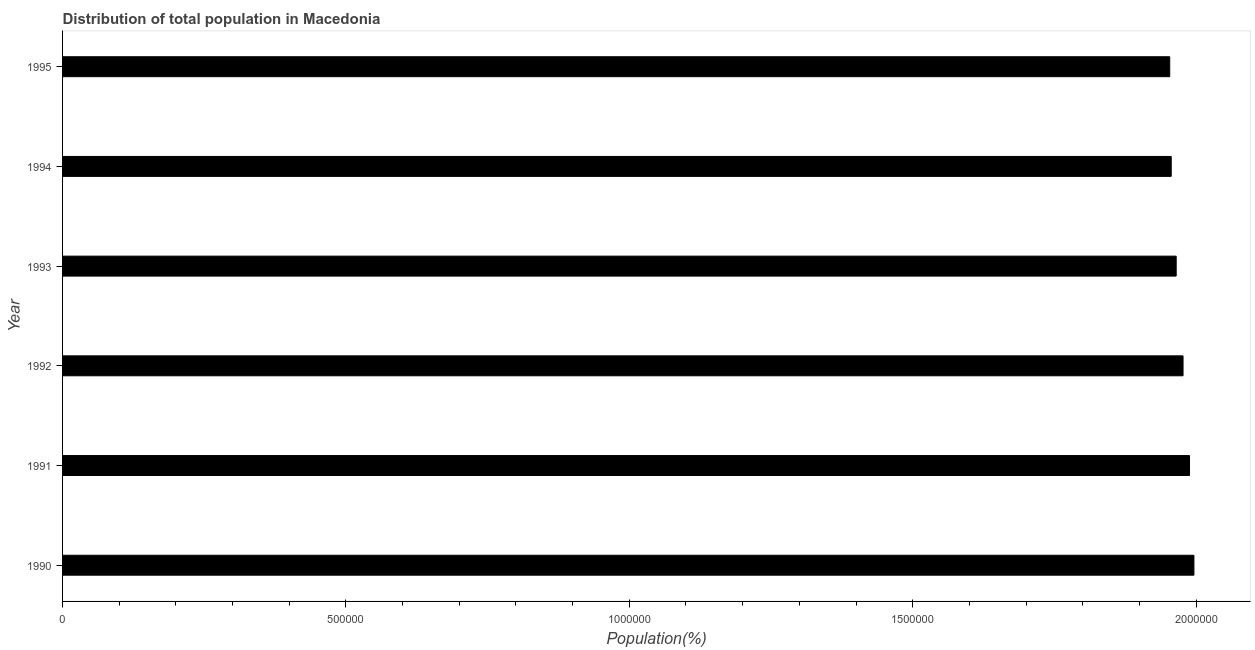What is the title of the graph?
Ensure brevity in your answer.  Distribution of total population in Macedonia . What is the label or title of the X-axis?
Your answer should be very brief. Population(%). What is the population in 1993?
Offer a terse response. 1.96e+06. Across all years, what is the maximum population?
Provide a short and direct response. 2.00e+06. Across all years, what is the minimum population?
Provide a succinct answer. 1.95e+06. In which year was the population maximum?
Your answer should be very brief. 1990. What is the sum of the population?
Give a very brief answer. 1.18e+07. What is the difference between the population in 1991 and 1994?
Your answer should be compact. 3.23e+04. What is the average population per year?
Provide a succinct answer. 1.97e+06. What is the median population?
Keep it short and to the point. 1.97e+06. Do a majority of the years between 1995 and 1994 (inclusive) have population greater than 1300000 %?
Provide a short and direct response. No. What is the ratio of the population in 1992 to that in 1995?
Your answer should be very brief. 1.01. Is the difference between the population in 1991 and 1995 greater than the difference between any two years?
Keep it short and to the point. No. What is the difference between the highest and the second highest population?
Give a very brief answer. 7769. Is the sum of the population in 1990 and 1994 greater than the maximum population across all years?
Provide a succinct answer. Yes. What is the difference between the highest and the lowest population?
Your answer should be very brief. 4.27e+04. Are the values on the major ticks of X-axis written in scientific E-notation?
Your response must be concise. No. What is the Population(%) of 1990?
Ensure brevity in your answer.  2.00e+06. What is the Population(%) of 1991?
Offer a very short reply. 1.99e+06. What is the Population(%) in 1992?
Provide a short and direct response. 1.98e+06. What is the Population(%) in 1993?
Offer a terse response. 1.96e+06. What is the Population(%) in 1994?
Your response must be concise. 1.96e+06. What is the Population(%) of 1995?
Offer a terse response. 1.95e+06. What is the difference between the Population(%) in 1990 and 1991?
Make the answer very short. 7769. What is the difference between the Population(%) in 1990 and 1992?
Ensure brevity in your answer.  1.92e+04. What is the difference between the Population(%) in 1990 and 1993?
Provide a succinct answer. 3.13e+04. What is the difference between the Population(%) in 1990 and 1994?
Keep it short and to the point. 4.01e+04. What is the difference between the Population(%) in 1990 and 1995?
Make the answer very short. 4.27e+04. What is the difference between the Population(%) in 1991 and 1992?
Offer a terse response. 1.14e+04. What is the difference between the Population(%) in 1991 and 1993?
Offer a terse response. 2.35e+04. What is the difference between the Population(%) in 1991 and 1994?
Your response must be concise. 3.23e+04. What is the difference between the Population(%) in 1991 and 1995?
Your response must be concise. 3.49e+04. What is the difference between the Population(%) in 1992 and 1993?
Offer a terse response. 1.21e+04. What is the difference between the Population(%) in 1992 and 1994?
Your answer should be compact. 2.09e+04. What is the difference between the Population(%) in 1992 and 1995?
Your answer should be very brief. 2.35e+04. What is the difference between the Population(%) in 1993 and 1994?
Provide a short and direct response. 8759. What is the difference between the Population(%) in 1993 and 1995?
Make the answer very short. 1.14e+04. What is the difference between the Population(%) in 1994 and 1995?
Your answer should be compact. 2621. What is the ratio of the Population(%) in 1990 to that in 1992?
Your answer should be very brief. 1.01. What is the ratio of the Population(%) in 1990 to that in 1993?
Offer a terse response. 1.02. What is the ratio of the Population(%) in 1990 to that in 1994?
Offer a terse response. 1.02. What is the ratio of the Population(%) in 1991 to that in 1994?
Make the answer very short. 1.02. What is the ratio of the Population(%) in 1992 to that in 1994?
Offer a very short reply. 1.01. What is the ratio of the Population(%) in 1992 to that in 1995?
Give a very brief answer. 1.01. What is the ratio of the Population(%) in 1993 to that in 1994?
Your answer should be compact. 1. What is the ratio of the Population(%) in 1993 to that in 1995?
Ensure brevity in your answer.  1.01. What is the ratio of the Population(%) in 1994 to that in 1995?
Offer a very short reply. 1. 